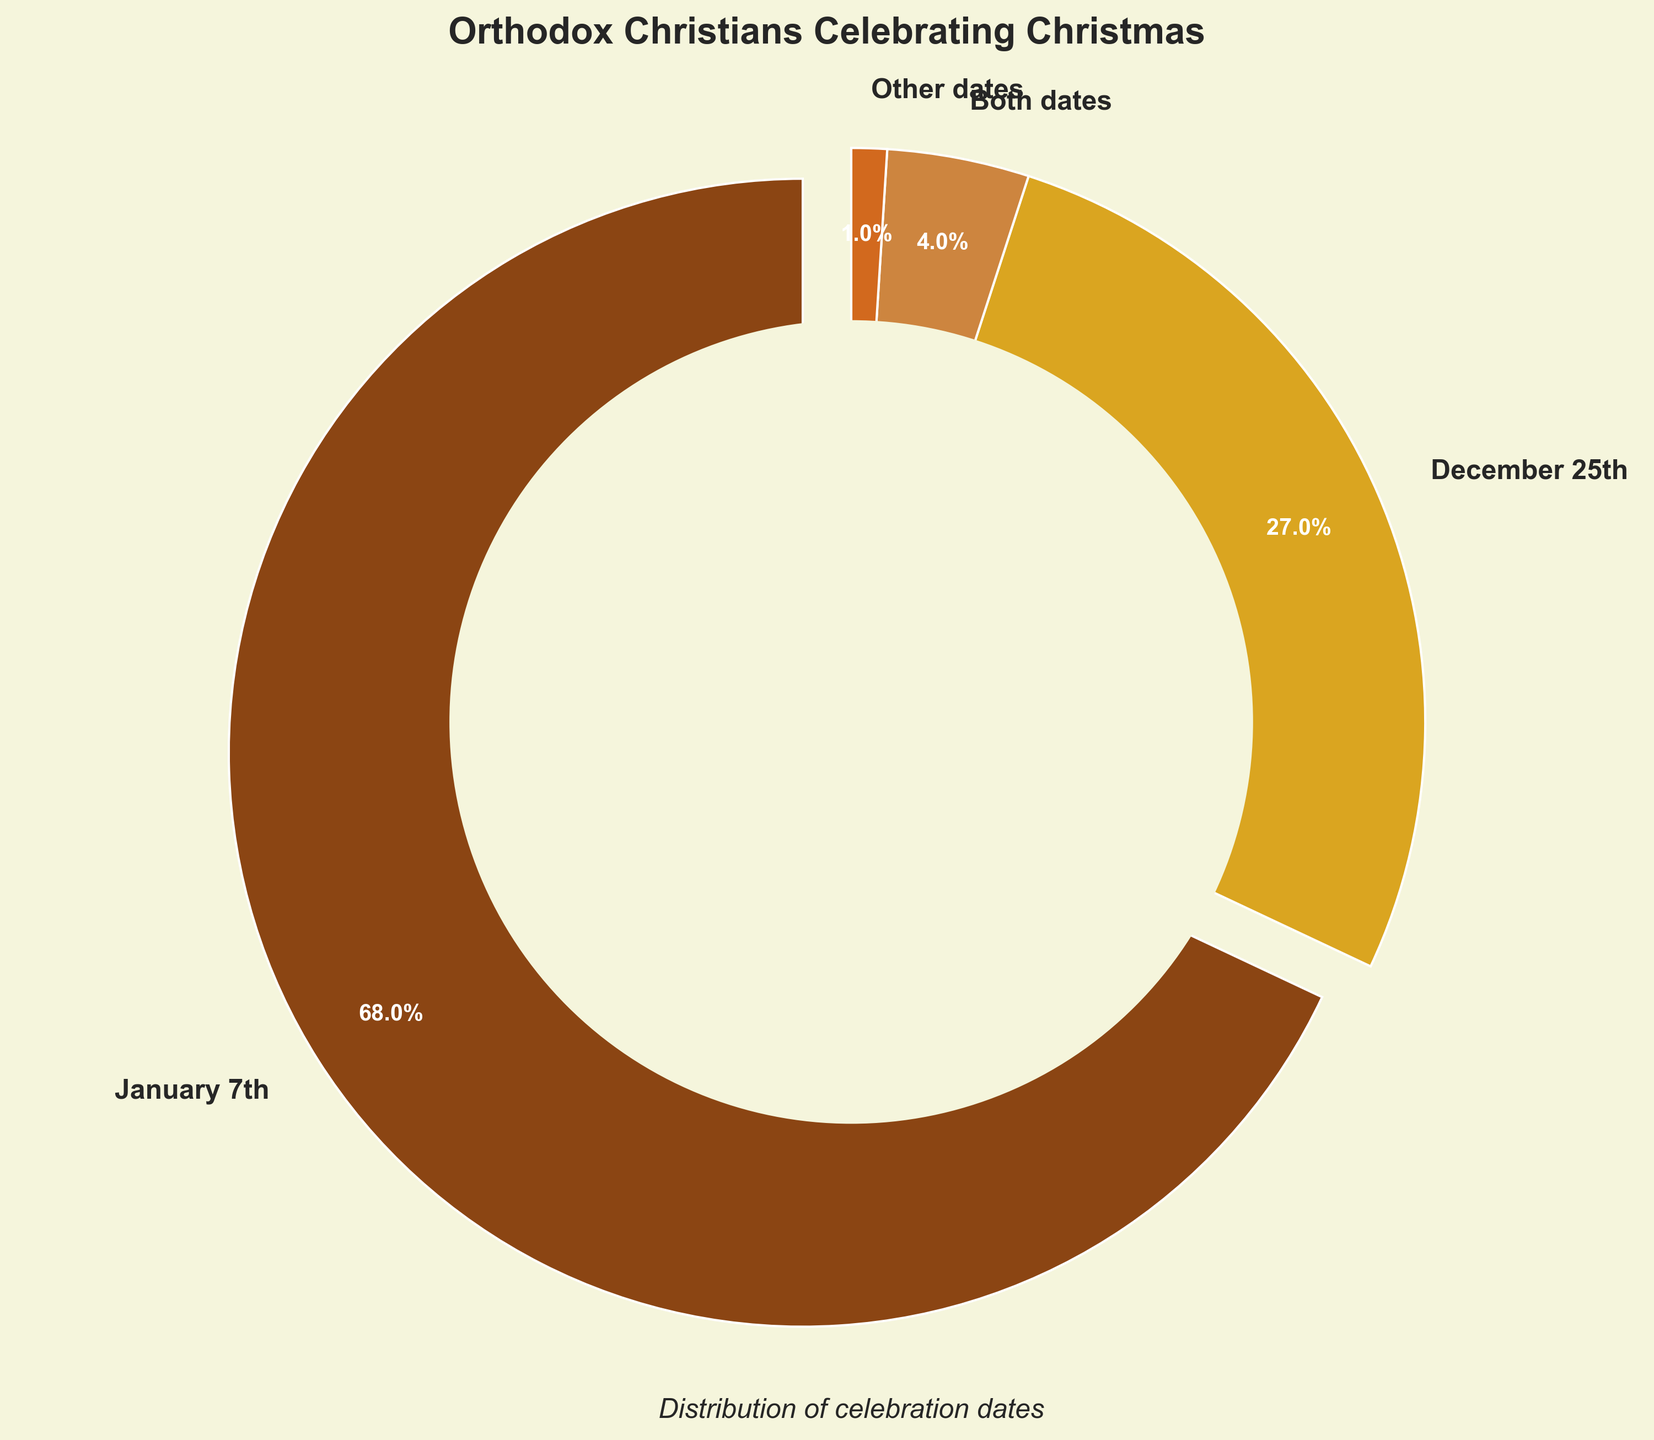What percentage of Orthodox Christians celebrate Christmas on January 7th? The pie chart shows that the majority segment representing 'January 7th'. The percentage associated with this segment is marked as 68%.
Answer: 68% What percentage more people celebrate Christmas on January 7th compared to December 25th? Subtract the percentage for December 25th from the percentage for January 7th which is 68% - 27%.
Answer: 41% Which date has the lowest percentage of people celebrating Christmas? By looking at the pie chart, we can see the smallest segment which represents 'Other dates' with 1%.
Answer: Other dates What is the combined percentage of people celebrating Christmas on both January 7th and December 25th? Add the percentages for January 7th and December 25th which is 68% + 27%.
Answer: 95% Is the percentage of people celebrating Christmas on January 7th greater than the combined percentage of those celebrating on December 25th and both dates? Add the percentages for December 25th and Both dates: 27% + 4% = 31%. Compare this with 68% for January 7th which is clearly greater.
Answer: Yes What is the second most popular date for celebrating Christmas among Orthodox Christians according to the data? By examining the pie chart, the second largest segment represents 'December 25th' with 27%.
Answer: December 25th What percentage of Orthodox Christians celebrate Christmas on either December 25th or both dates? Add the percentages for December 25th and Both dates: 27% + 4% = 31%.
Answer: 31% What color represents the segment for people celebrating Christmas on January 7th in the pie chart? From the pie chart, the segment for January 7th is colored brown.
Answer: brown Which is the larger percentage: those who celebrate on both dates or those on other dates? Compare the percentages for Both dates (4%) and Other dates (1%). 4% is greater than 1%.
Answer: Both dates If you sum up the percentages of people celebrating Christmas on dates other than January 7th, what percentage do you get? Add the percentages for December 25th, Both dates and Other dates: 27% + 4% + 1%. The result is 32%.
Answer: 32% 